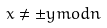Convert formula to latex. <formula><loc_0><loc_0><loc_500><loc_500>x \ne \pm y m o d n</formula> 